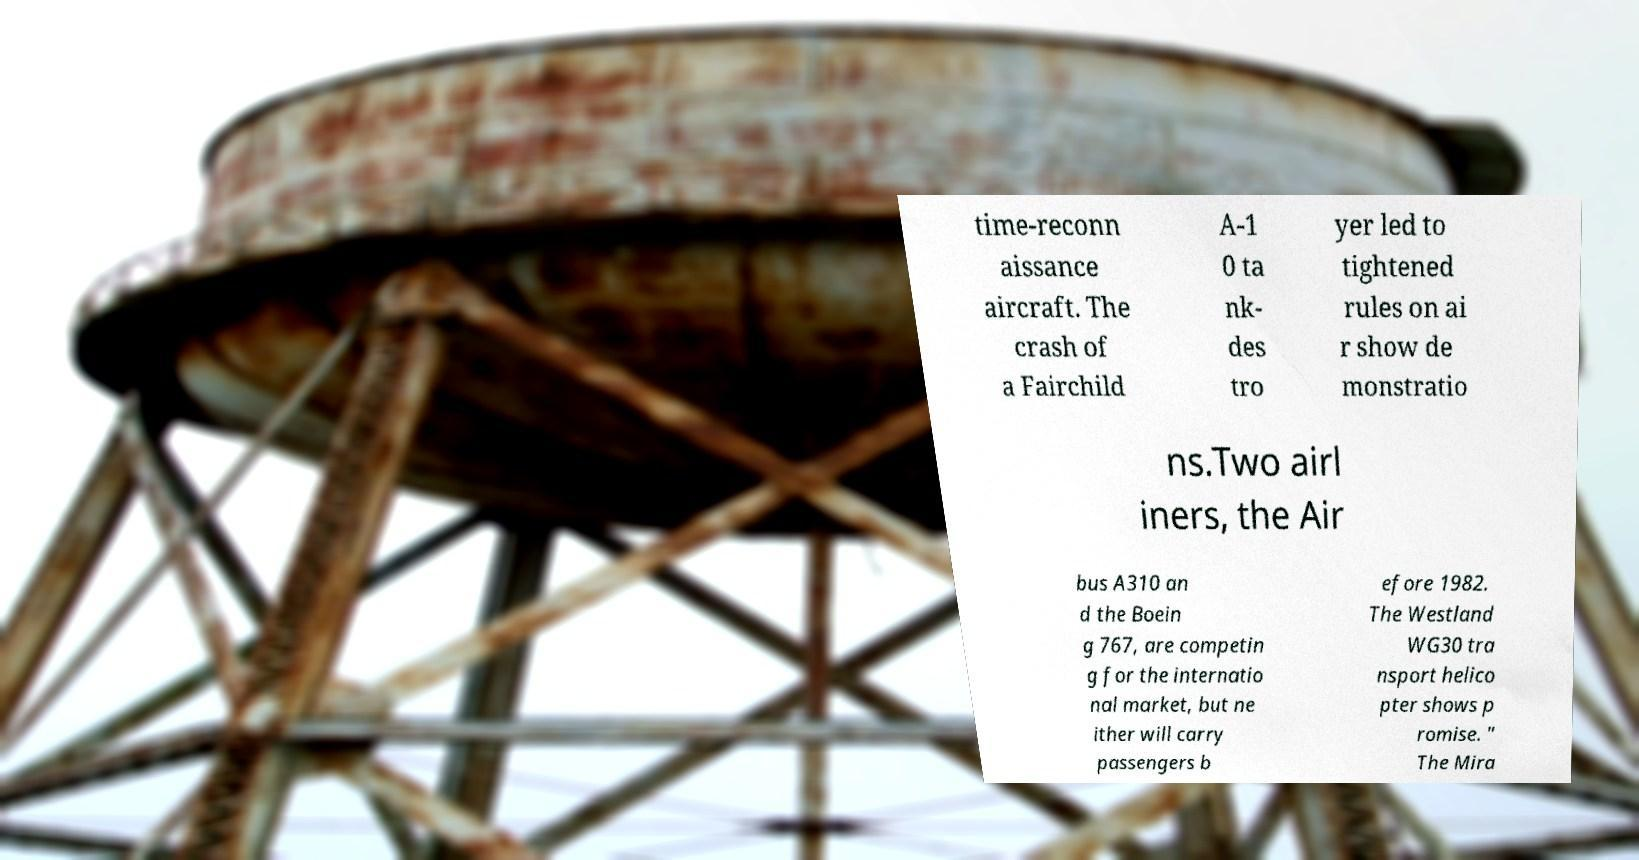Please identify and transcribe the text found in this image. time-reconn aissance aircraft. The crash of a Fairchild A-1 0 ta nk- des tro yer led to tightened rules on ai r show de monstratio ns.Two airl iners, the Air bus A310 an d the Boein g 767, are competin g for the internatio nal market, but ne ither will carry passengers b efore 1982. The Westland WG30 tra nsport helico pter shows p romise. " The Mira 